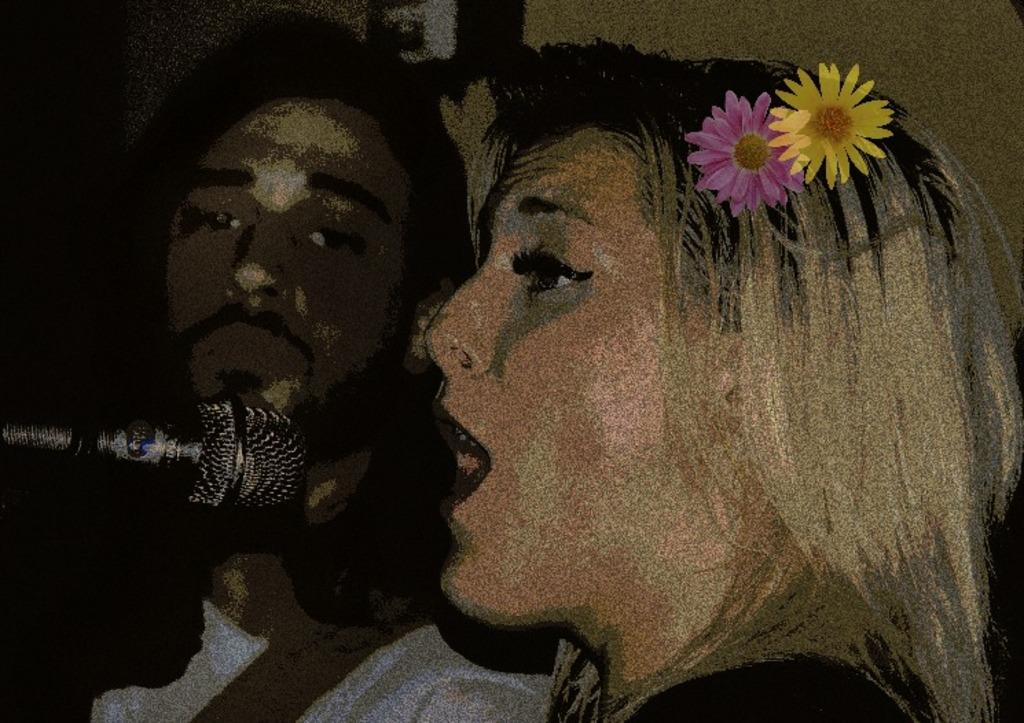How many people are present in the image? There are two people, a man and a woman, present in the image. What is the woman holding in her hair? The woman has flowers in her hair. What object is located to the left of the image? There is a microphone to the left of the image. What can be seen in the background of the image? There is a wall in the background of the image. What type of cactus can be seen growing on the wall in the image? There is no cactus visible on the wall in the image. What advice is the man giving to the woman in the image? The image does not provide any information about the man giving advice to the woman. 